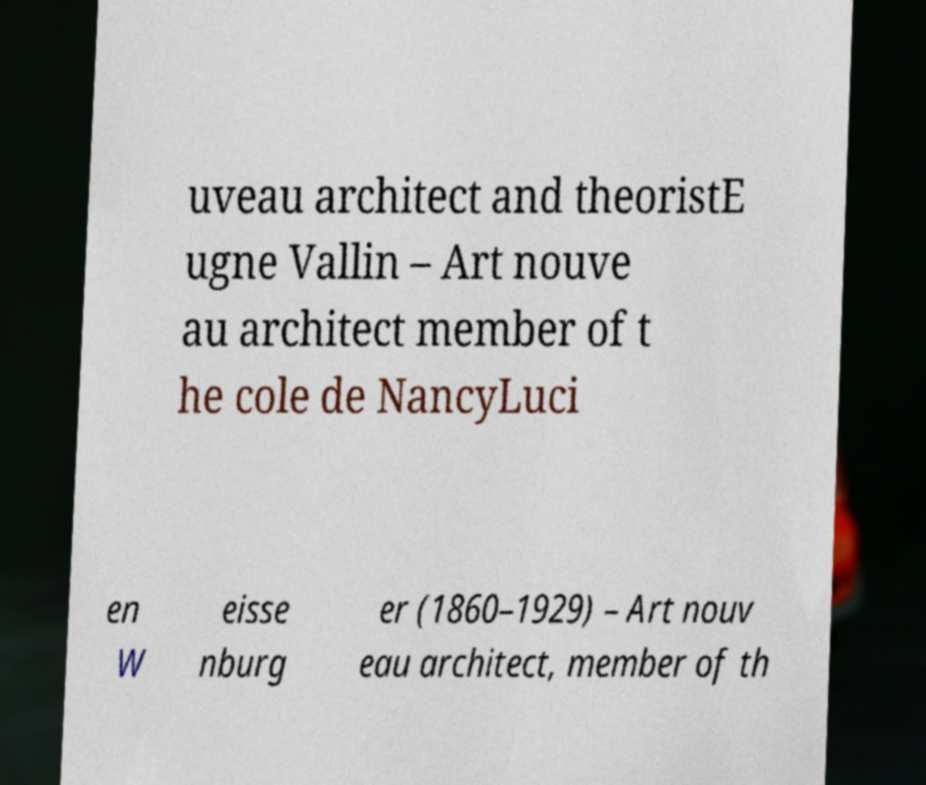Could you assist in decoding the text presented in this image and type it out clearly? uveau architect and theoristE ugne Vallin – Art nouve au architect member of t he cole de NancyLuci en W eisse nburg er (1860–1929) – Art nouv eau architect, member of th 